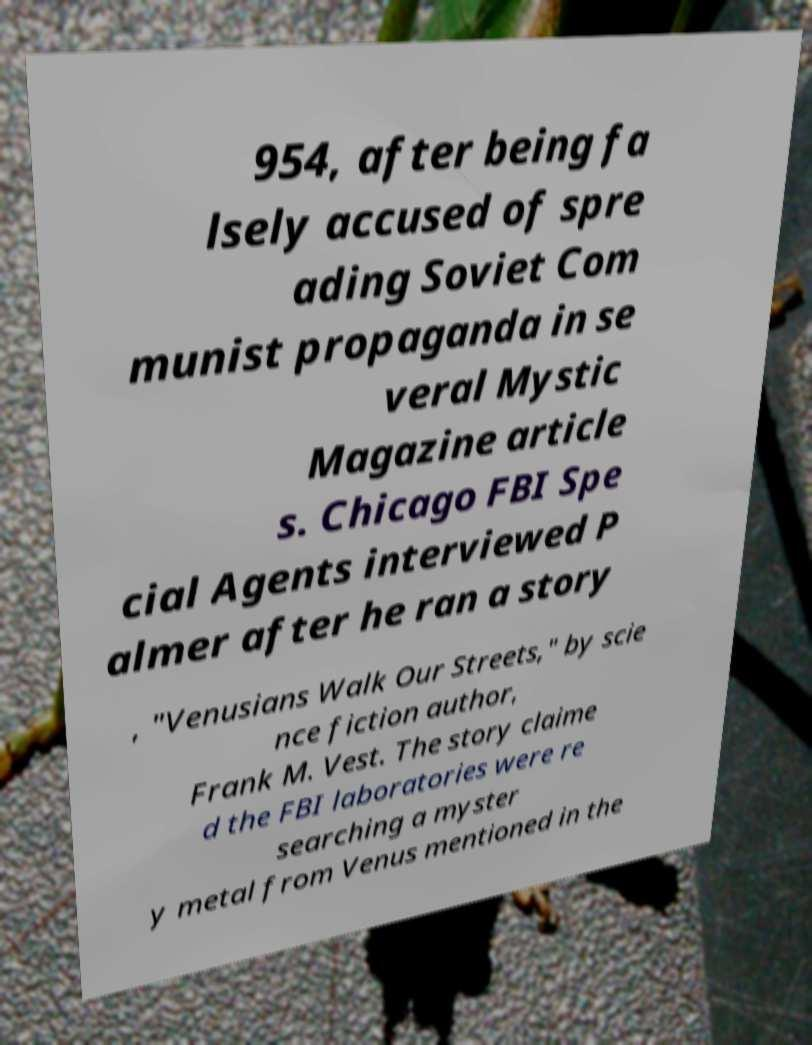Could you assist in decoding the text presented in this image and type it out clearly? 954, after being fa lsely accused of spre ading Soviet Com munist propaganda in se veral Mystic Magazine article s. Chicago FBI Spe cial Agents interviewed P almer after he ran a story , "Venusians Walk Our Streets," by scie nce fiction author, Frank M. Vest. The story claime d the FBI laboratories were re searching a myster y metal from Venus mentioned in the 